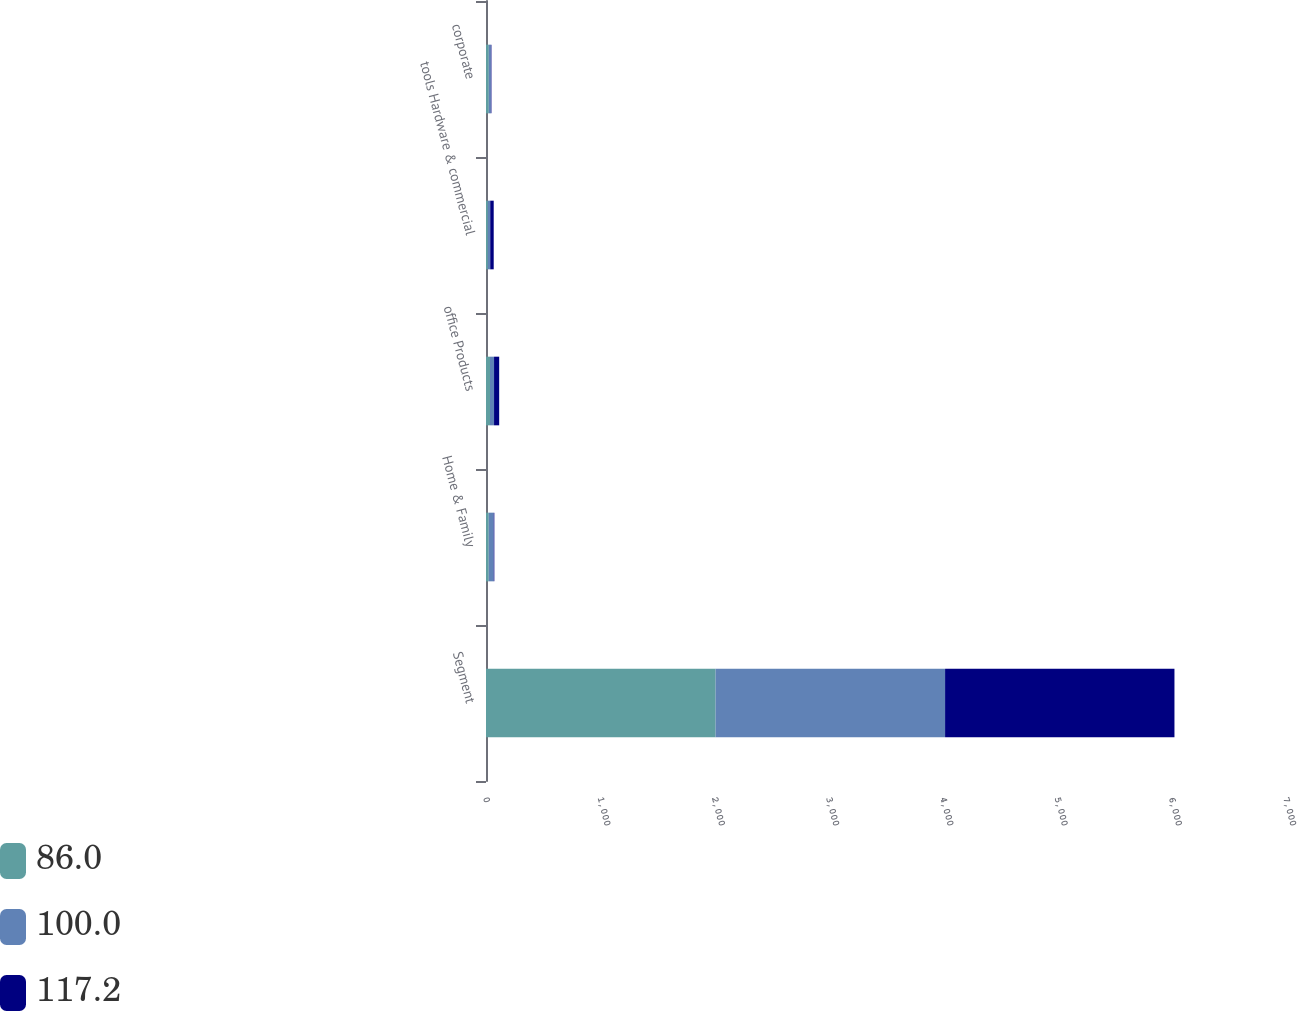Convert chart. <chart><loc_0><loc_0><loc_500><loc_500><stacked_bar_chart><ecel><fcel>Segment<fcel>Home & Family<fcel>office Products<fcel>tools Hardware & commercial<fcel>corporate<nl><fcel>86<fcel>2009<fcel>24<fcel>34.8<fcel>16.6<fcel>24.6<nl><fcel>100<fcel>2008<fcel>43.5<fcel>35.6<fcel>20.4<fcel>17.7<nl><fcel>117.2<fcel>2007<fcel>5.5<fcel>45<fcel>30.4<fcel>5.1<nl></chart> 